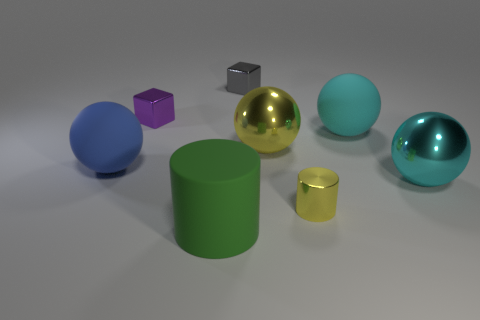How many metallic things are the same color as the tiny cylinder?
Ensure brevity in your answer.  1. How many yellow metal objects are there?
Your answer should be compact. 2. What number of yellow cylinders have the same material as the large yellow object?
Your answer should be very brief. 1. There is a purple object that is the same shape as the small gray shiny object; what size is it?
Your answer should be very brief. Small. What material is the large blue sphere?
Make the answer very short. Rubber. The large object that is left of the matte object that is in front of the large object that is to the left of the big cylinder is made of what material?
Offer a terse response. Rubber. There is another big metallic thing that is the same shape as the large cyan metal thing; what color is it?
Give a very brief answer. Yellow. Do the large metallic ball right of the small metal cylinder and the big matte object that is right of the big green rubber thing have the same color?
Your response must be concise. Yes. Is the number of cyan shiny spheres in front of the purple metal cube greater than the number of large purple blocks?
Your answer should be compact. Yes. What number of other objects are there of the same size as the cyan rubber thing?
Ensure brevity in your answer.  4. 